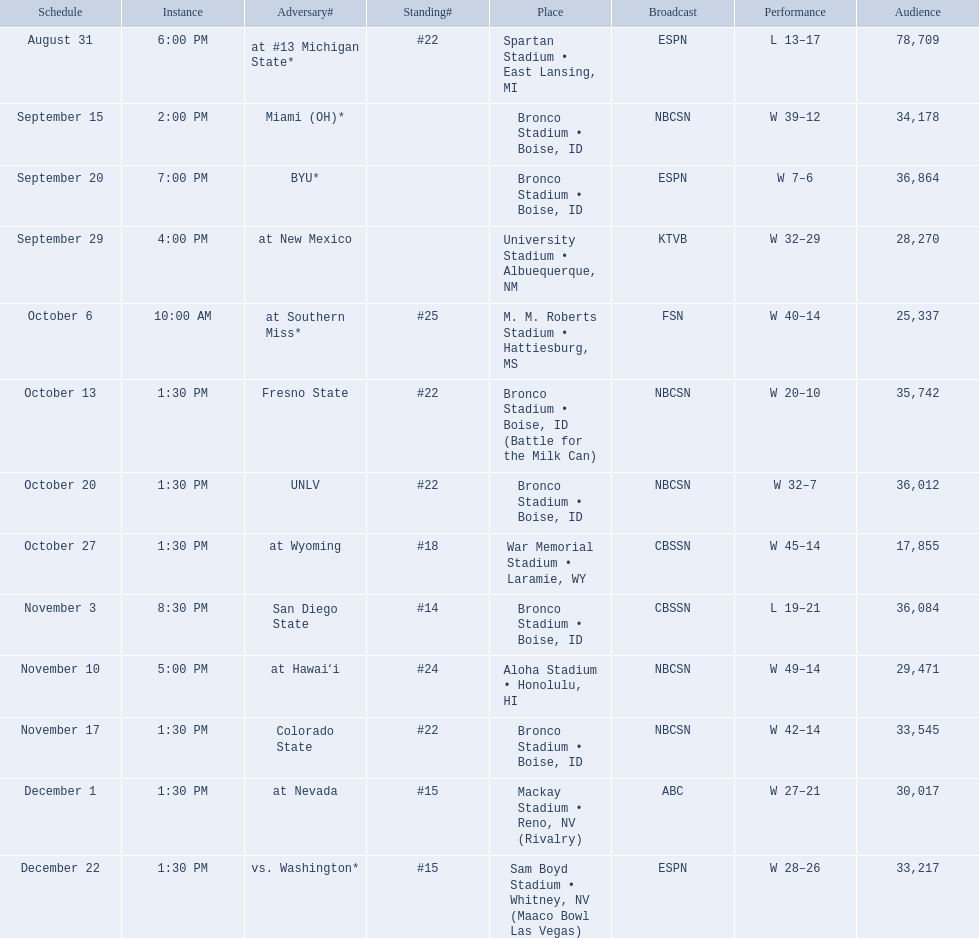What are the opponents to the  2012 boise state broncos football team? At #13 michigan state*, miami (oh)*, byu*, at new mexico, at southern miss*, fresno state, unlv, at wyoming, san diego state, at hawaiʻi, colorado state, at nevada, vs. washington*. Which is the highest ranked of the teams? San Diego State. 